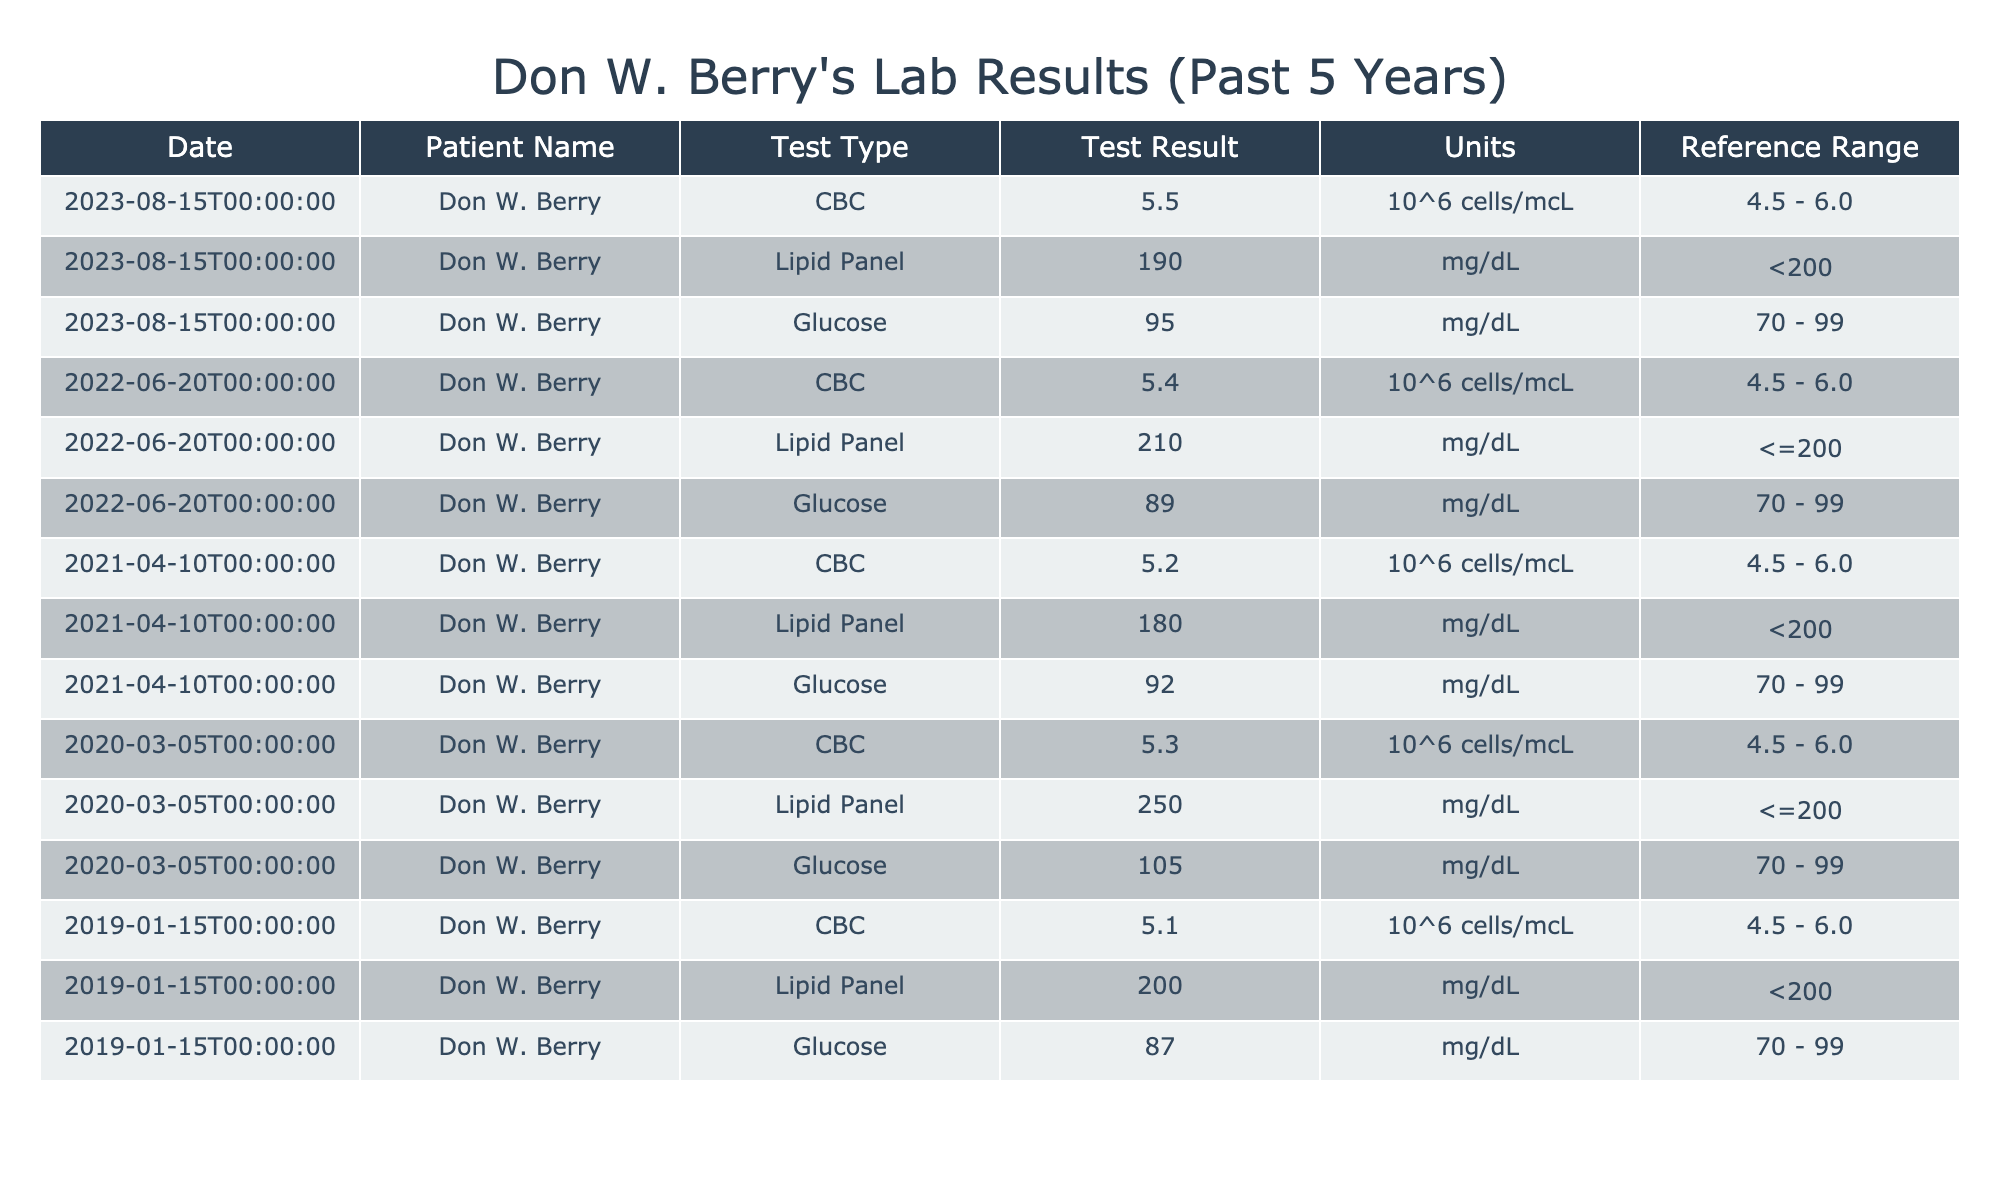What was Don W. Berry's CBC result on August 15, 2023? The table shows the CBC result under the date August 15, 2023, which is listed as 5.5, with units of 10^6 cells/mcL.
Answer: 5.5 What was the highest Glucose level recorded in the past 5 years? Looking at the table, the Glucose levels for each year are 95, 89, 92, 105, and 87 mg/dL. Among these, the highest is 105 mg/dL from the test on March 5, 2020.
Answer: 105 mg/dL Was the Lipid Panel result above the reference range at any point? Reviewing the Lipid Panel results, in 2020, the result of 250 mg/dL exceeds the reference range of ≤200 mg/dL indicating it was above normal at that time.
Answer: Yes What is the average CBC count over the last 5 years? The CBC counts are 5.5, 5.4, 5.2, 5.3, and 5.1. Summing these gives 5.5 + 5.4 + 5.2 + 5.3 + 5.1 = 27.5. Dividing by the number of tests (5) results in an average of 27.5 / 5 = 5.5.
Answer: 5.5 Did the Glucose level increase or decrease over the five years? The Glucose levels in 2019, 2020, 2021, 2022, and 2023 are 87, 105, 92, 89, and 95 mg/dL, respectively. Comparing these, the levels initially increased from 87 in 2019 to 105 in 2020, followed by a decrease to 89 and then an increase to 95 in 2023, indicating an overall fluctuating trend with no clear increase or decrease.
Answer: Fluctuated What was the change in Don W. Berry's Lipid Panel results from 2019 to 2023? In 2019, the Lipid Panel result was 200 mg/dL. In 2023, it was 190 mg/dL. The difference between these two values is 200 - 190 = 10 mg/dL, indicating a decrease in Lipid Panel result over this period.
Answer: Decreased by 10 mg/dL Was Don W. Berry's glucose level ever below 90 mg/dL? The Glucose levels recorded are 87, 105, 92, 89, and 95 mg/dL. The value of 87 mg/dL, which is below 90 mg/dL, was recorded in January 2019.
Answer: Yes What year had the highest recorded Lipid Panel result? The Lipid Panel results recorded are 250, 210, 180, 190, and 200 mg/dL from the years 2020, 2022, 2021, 2023, and 2019, respectively. The highest among these is 250 mg/dL from 2020.
Answer: 2020 